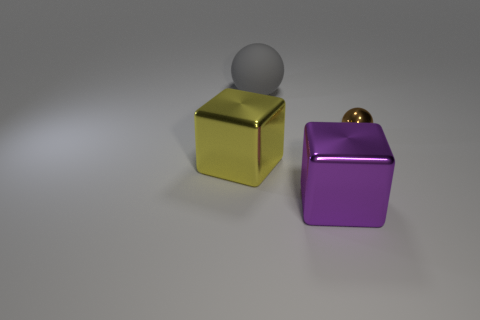Add 4 purple cubes. How many objects exist? 8 Add 2 gray matte balls. How many gray matte balls exist? 3 Subtract 0 blue balls. How many objects are left? 4 Subtract all large green cylinders. Subtract all tiny brown shiny things. How many objects are left? 3 Add 3 small metal balls. How many small metal balls are left? 4 